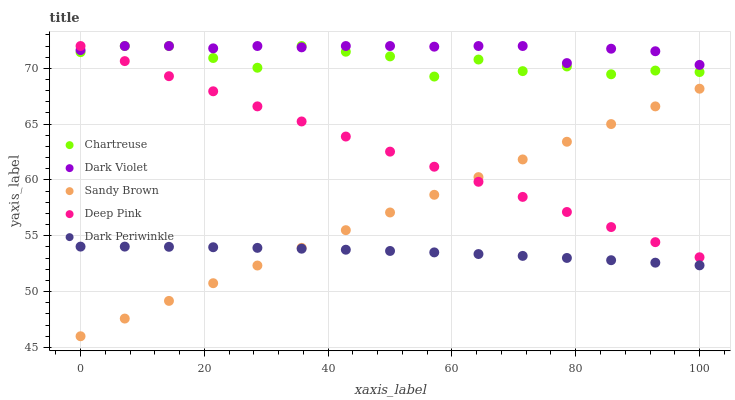Does Dark Periwinkle have the minimum area under the curve?
Answer yes or no. Yes. Does Dark Violet have the maximum area under the curve?
Answer yes or no. Yes. Does Deep Pink have the minimum area under the curve?
Answer yes or no. No. Does Deep Pink have the maximum area under the curve?
Answer yes or no. No. Is Sandy Brown the smoothest?
Answer yes or no. Yes. Is Chartreuse the roughest?
Answer yes or no. Yes. Is Deep Pink the smoothest?
Answer yes or no. No. Is Deep Pink the roughest?
Answer yes or no. No. Does Sandy Brown have the lowest value?
Answer yes or no. Yes. Does Deep Pink have the lowest value?
Answer yes or no. No. Does Dark Violet have the highest value?
Answer yes or no. Yes. Does Sandy Brown have the highest value?
Answer yes or no. No. Is Dark Periwinkle less than Chartreuse?
Answer yes or no. Yes. Is Dark Violet greater than Sandy Brown?
Answer yes or no. Yes. Does Sandy Brown intersect Dark Periwinkle?
Answer yes or no. Yes. Is Sandy Brown less than Dark Periwinkle?
Answer yes or no. No. Is Sandy Brown greater than Dark Periwinkle?
Answer yes or no. No. Does Dark Periwinkle intersect Chartreuse?
Answer yes or no. No. 